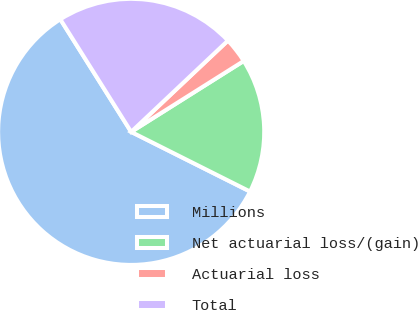Convert chart to OTSL. <chart><loc_0><loc_0><loc_500><loc_500><pie_chart><fcel>Millions<fcel>Net actuarial loss/(gain)<fcel>Actuarial loss<fcel>Total<nl><fcel>58.66%<fcel>16.35%<fcel>3.09%<fcel>21.9%<nl></chart> 